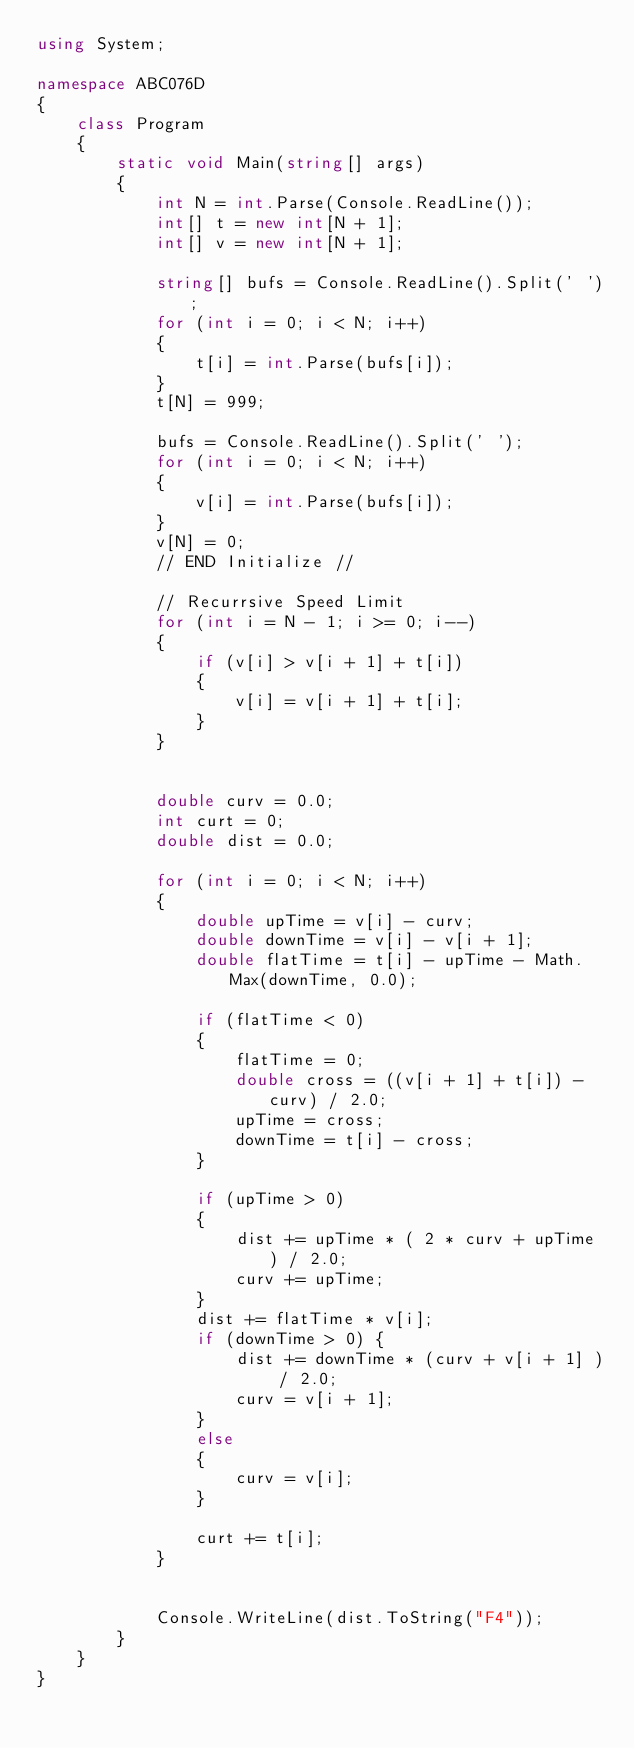Convert code to text. <code><loc_0><loc_0><loc_500><loc_500><_C#_>using System;

namespace ABC076D
{
    class Program
    {
        static void Main(string[] args)
        {
            int N = int.Parse(Console.ReadLine());
            int[] t = new int[N + 1];
            int[] v = new int[N + 1];

            string[] bufs = Console.ReadLine().Split(' ');
            for (int i = 0; i < N; i++)
            {
                t[i] = int.Parse(bufs[i]);
            }
            t[N] = 999;

            bufs = Console.ReadLine().Split(' ');
            for (int i = 0; i < N; i++)
            {
                v[i] = int.Parse(bufs[i]);
            }
            v[N] = 0;
            // END Initialize //

            // Recurrsive Speed Limit
            for (int i = N - 1; i >= 0; i--)
            {
                if (v[i] > v[i + 1] + t[i])
                {
                    v[i] = v[i + 1] + t[i];
                }
            }


            double curv = 0.0;
            int curt = 0;
            double dist = 0.0;

            for (int i = 0; i < N; i++)
            {
                double upTime = v[i] - curv;
                double downTime = v[i] - v[i + 1];
                double flatTime = t[i] - upTime - Math.Max(downTime, 0.0);

                if (flatTime < 0)
                {
                    flatTime = 0;
                    double cross = ((v[i + 1] + t[i]) - curv) / 2.0;
                    upTime = cross;
                    downTime = t[i] - cross;
                }

                if (upTime > 0)
                {
                    dist += upTime * ( 2 * curv + upTime ) / 2.0;
                    curv += upTime;
                }
                dist += flatTime * v[i];
                if (downTime > 0) {
                    dist += downTime * (curv + v[i + 1] ) / 2.0;
                    curv = v[i + 1];
                }
                else
                {
                    curv = v[i];
                }

                curt += t[i];
            }


            Console.WriteLine(dist.ToString("F4"));
        }
    }
}
</code> 